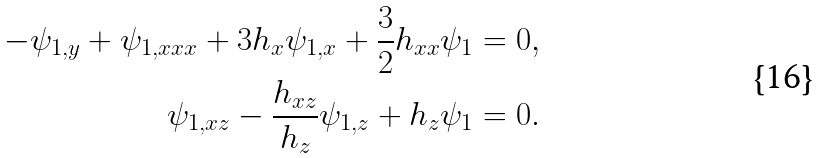<formula> <loc_0><loc_0><loc_500><loc_500>- \psi _ { 1 , y } + \psi _ { 1 , x x x } + 3 h _ { x } \psi _ { 1 , x } + \frac { 3 } { 2 } h _ { x x } \psi _ { 1 } = 0 , \\ \psi _ { 1 , x z } - \frac { h _ { x z } } { h _ { z } } \psi _ { 1 , z } + h _ { z } \psi _ { 1 } = 0 .</formula> 